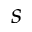Convert formula to latex. <formula><loc_0><loc_0><loc_500><loc_500>s</formula> 